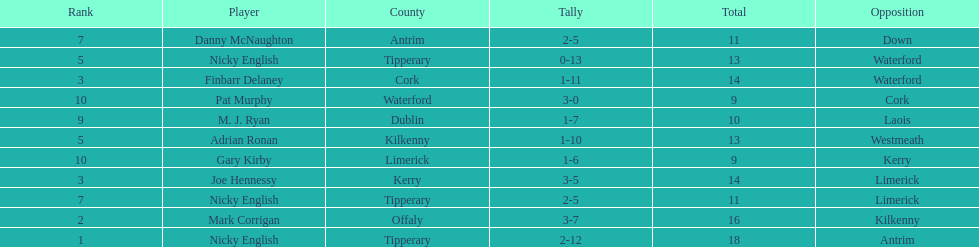Which player ranked the most? Nicky English. 